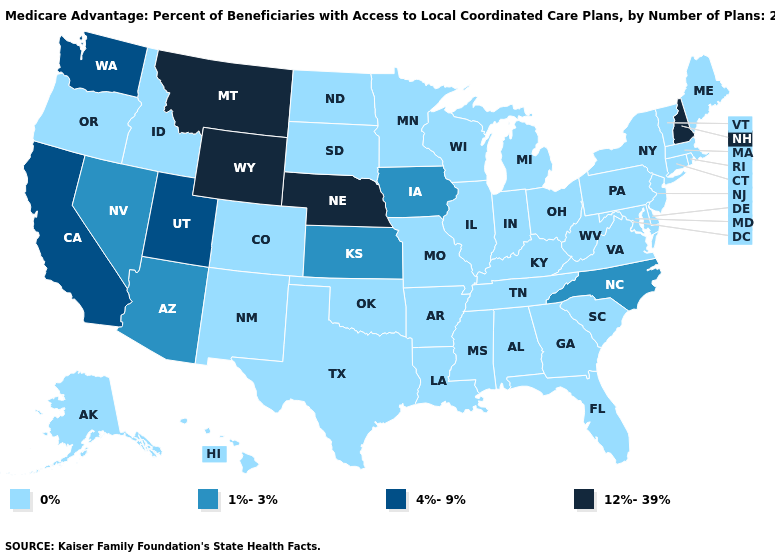Which states hav the highest value in the Northeast?
Short answer required. New Hampshire. Which states have the highest value in the USA?
Keep it brief. Montana, Nebraska, New Hampshire, Wyoming. What is the value of Ohio?
Answer briefly. 0%. Name the states that have a value in the range 12%-39%?
Concise answer only. Montana, Nebraska, New Hampshire, Wyoming. Name the states that have a value in the range 12%-39%?
Give a very brief answer. Montana, Nebraska, New Hampshire, Wyoming. Does New Hampshire have the lowest value in the USA?
Be succinct. No. What is the value of Georgia?
Concise answer only. 0%. What is the highest value in the USA?
Answer briefly. 12%-39%. Name the states that have a value in the range 4%-9%?
Write a very short answer. California, Utah, Washington. What is the value of Oklahoma?
Concise answer only. 0%. Does the first symbol in the legend represent the smallest category?
Short answer required. Yes. What is the highest value in the USA?
Give a very brief answer. 12%-39%. What is the lowest value in the USA?
Quick response, please. 0%. Is the legend a continuous bar?
Give a very brief answer. No. What is the value of Missouri?
Be succinct. 0%. 